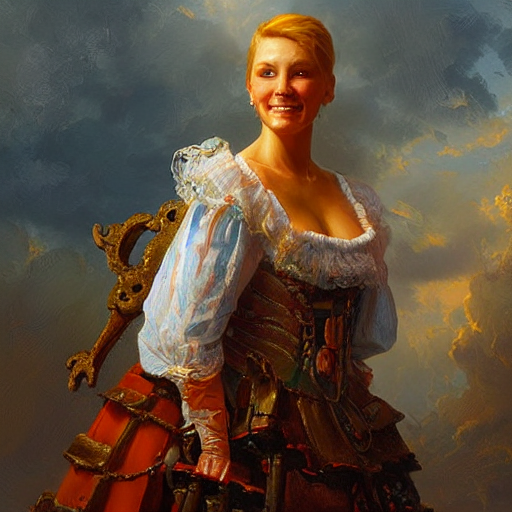What time of day does the lighting suggest in the painting? The warm hues and the direction of light in the painting suggest it could be late afternoon or early evening, a time often referred to as the 'golden hour' in art and photography for its soft, flattering light. 